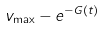Convert formula to latex. <formula><loc_0><loc_0><loc_500><loc_500>v _ { \max } - e ^ { - G ( t ) }</formula> 